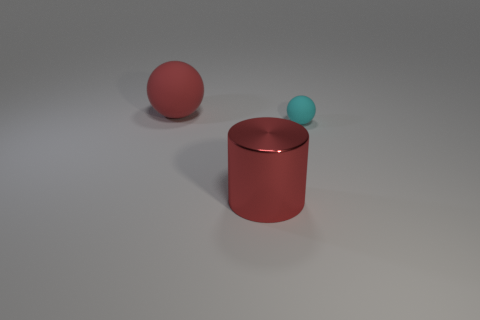Does the large rubber object have the same shape as the metallic object?
Ensure brevity in your answer.  No. There is a sphere that is the same color as the big shiny cylinder; what material is it?
Your answer should be compact. Rubber. There is a matte object to the left of the tiny cyan rubber object that is on the right side of the big metal thing; is there a red shiny cylinder behind it?
Provide a short and direct response. No. Is the material of the object on the right side of the large metal cylinder the same as the big thing in front of the cyan rubber sphere?
Provide a succinct answer. No. How many things are either large red matte things or red metallic objects on the right side of the big sphere?
Your answer should be compact. 2. How many cyan matte objects have the same shape as the large metallic object?
Your answer should be very brief. 0. There is a red cylinder that is the same size as the red ball; what material is it?
Your answer should be compact. Metal. What size is the rubber ball that is right of the large red object to the right of the big object that is behind the large metallic cylinder?
Your answer should be compact. Small. There is a big object left of the large red metallic thing; does it have the same color as the rubber object that is on the right side of the red matte thing?
Your answer should be very brief. No. How many gray things are either cylinders or tiny balls?
Your response must be concise. 0. 